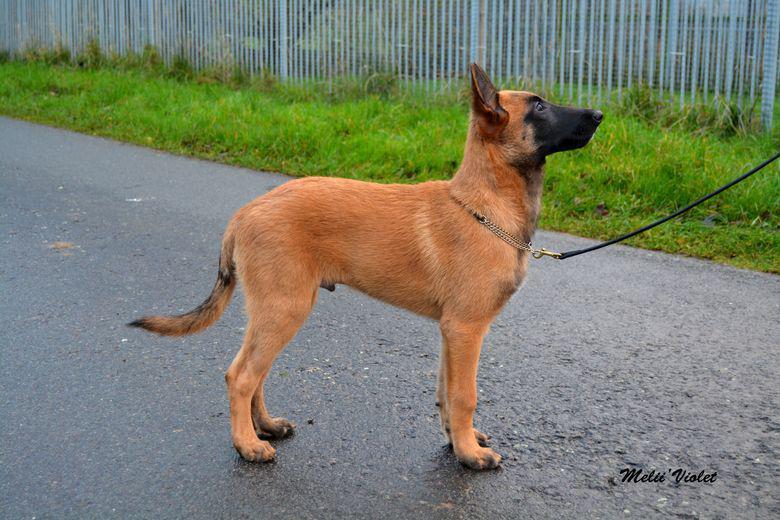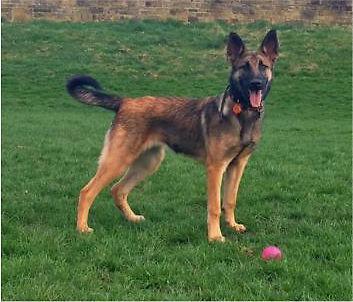The first image is the image on the left, the second image is the image on the right. Evaluate the accuracy of this statement regarding the images: "There are two dogs in total and one of them is standing on grass.›". Is it true? Answer yes or no. Yes. The first image is the image on the left, the second image is the image on the right. For the images displayed, is the sentence "An image shows only one dog, which is standing on a hard surface and wearing a leash." factually correct? Answer yes or no. Yes. 